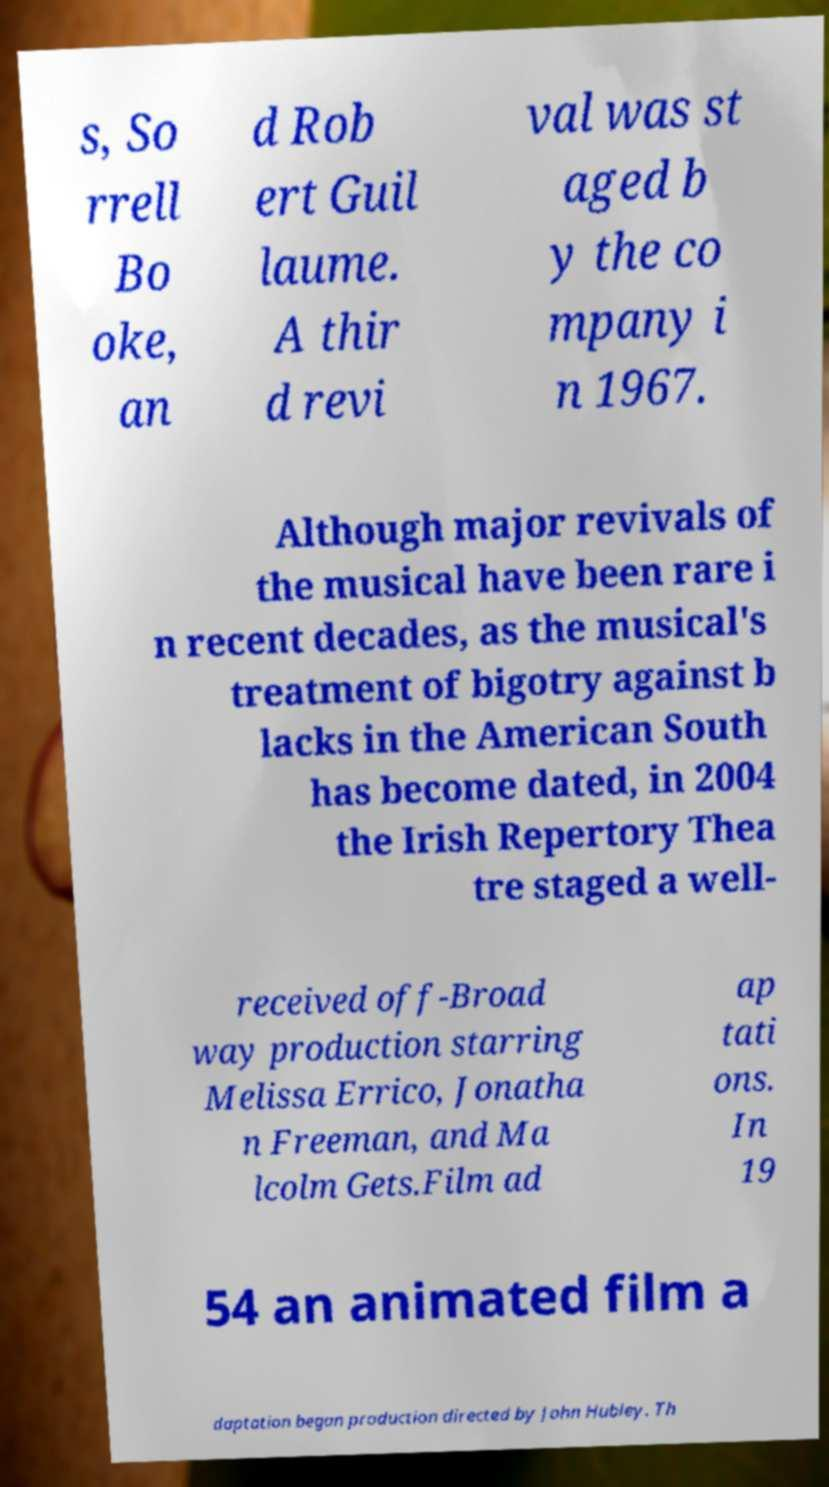For documentation purposes, I need the text within this image transcribed. Could you provide that? s, So rrell Bo oke, an d Rob ert Guil laume. A thir d revi val was st aged b y the co mpany i n 1967. Although major revivals of the musical have been rare i n recent decades, as the musical's treatment of bigotry against b lacks in the American South has become dated, in 2004 the Irish Repertory Thea tre staged a well- received off-Broad way production starring Melissa Errico, Jonatha n Freeman, and Ma lcolm Gets.Film ad ap tati ons. In 19 54 an animated film a daptation began production directed by John Hubley. Th 